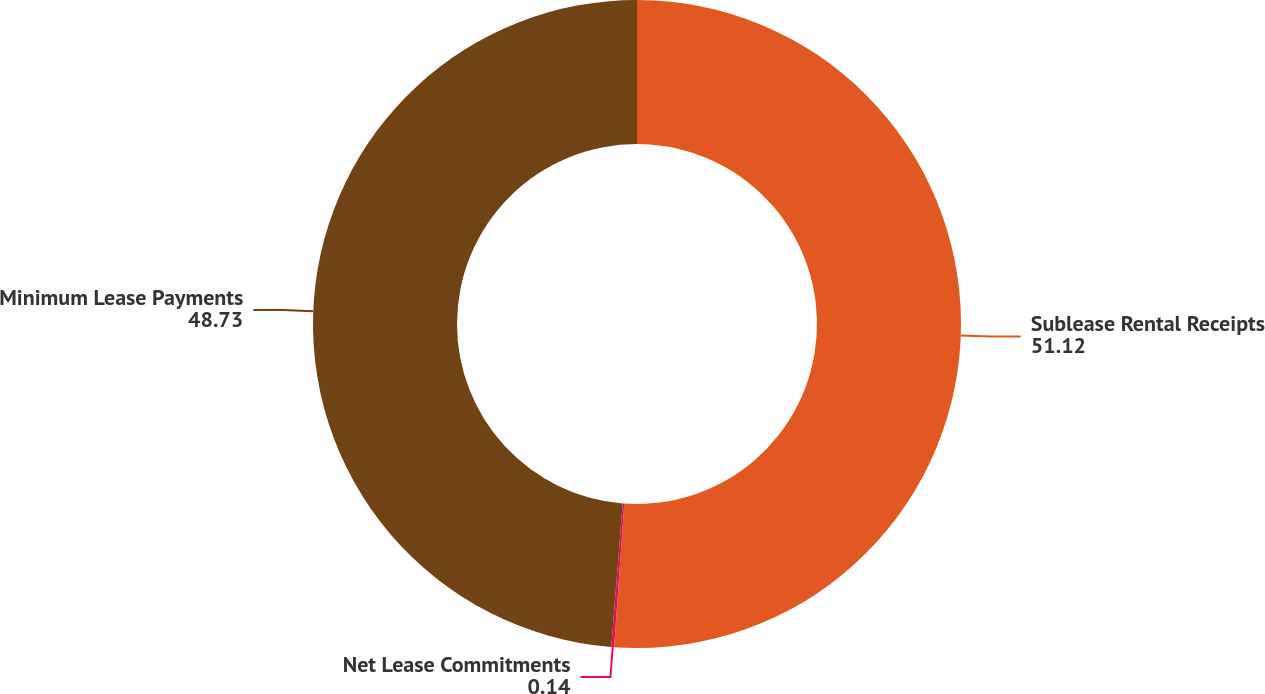Convert chart. <chart><loc_0><loc_0><loc_500><loc_500><pie_chart><fcel>Sublease Rental Receipts<fcel>Net Lease Commitments<fcel>Minimum Lease Payments<nl><fcel>51.12%<fcel>0.14%<fcel>48.73%<nl></chart> 